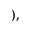Convert formula to latex. <formula><loc_0><loc_0><loc_500><loc_500>) ,</formula> 